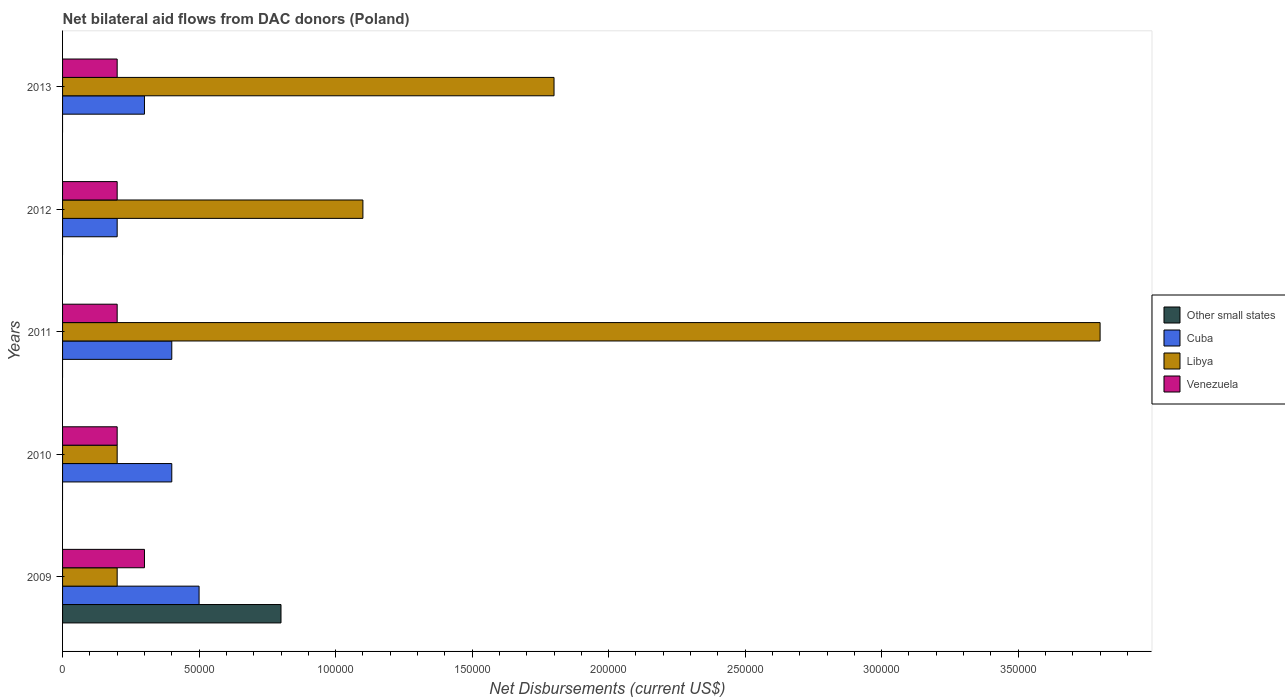How many groups of bars are there?
Your response must be concise. 5. Are the number of bars per tick equal to the number of legend labels?
Your answer should be compact. No. How many bars are there on the 4th tick from the bottom?
Ensure brevity in your answer.  3. What is the label of the 4th group of bars from the top?
Keep it short and to the point. 2010. What is the net bilateral aid flows in Other small states in 2010?
Your response must be concise. 0. Across all years, what is the minimum net bilateral aid flows in Venezuela?
Offer a terse response. 2.00e+04. What is the total net bilateral aid flows in Other small states in the graph?
Give a very brief answer. 8.00e+04. What is the difference between the net bilateral aid flows in Cuba in 2011 and that in 2012?
Your answer should be very brief. 2.00e+04. What is the difference between the net bilateral aid flows in Cuba in 2010 and the net bilateral aid flows in Venezuela in 2013?
Keep it short and to the point. 2.00e+04. What is the average net bilateral aid flows in Venezuela per year?
Your answer should be compact. 2.20e+04. What is the ratio of the net bilateral aid flows in Venezuela in 2009 to that in 2010?
Offer a terse response. 1.5. What is the difference between the highest and the lowest net bilateral aid flows in Other small states?
Ensure brevity in your answer.  8.00e+04. Is it the case that in every year, the sum of the net bilateral aid flows in Venezuela and net bilateral aid flows in Cuba is greater than the sum of net bilateral aid flows in Other small states and net bilateral aid flows in Libya?
Your answer should be compact. Yes. Is it the case that in every year, the sum of the net bilateral aid flows in Venezuela and net bilateral aid flows in Other small states is greater than the net bilateral aid flows in Libya?
Make the answer very short. No. How many bars are there?
Offer a terse response. 16. Are all the bars in the graph horizontal?
Keep it short and to the point. Yes. How many years are there in the graph?
Your answer should be very brief. 5. Where does the legend appear in the graph?
Make the answer very short. Center right. What is the title of the graph?
Provide a short and direct response. Net bilateral aid flows from DAC donors (Poland). Does "Montenegro" appear as one of the legend labels in the graph?
Your response must be concise. No. What is the label or title of the X-axis?
Your answer should be compact. Net Disbursements (current US$). What is the Net Disbursements (current US$) of Other small states in 2009?
Offer a very short reply. 8.00e+04. What is the Net Disbursements (current US$) in Venezuela in 2009?
Give a very brief answer. 3.00e+04. What is the Net Disbursements (current US$) in Other small states in 2010?
Your response must be concise. 0. What is the Net Disbursements (current US$) in Venezuela in 2010?
Give a very brief answer. 2.00e+04. What is the Net Disbursements (current US$) in Libya in 2011?
Your answer should be compact. 3.80e+05. What is the Net Disbursements (current US$) of Other small states in 2012?
Provide a succinct answer. 0. What is the Net Disbursements (current US$) in Venezuela in 2012?
Make the answer very short. 2.00e+04. What is the Net Disbursements (current US$) in Venezuela in 2013?
Offer a terse response. 2.00e+04. Across all years, what is the maximum Net Disbursements (current US$) of Venezuela?
Your response must be concise. 3.00e+04. Across all years, what is the minimum Net Disbursements (current US$) in Other small states?
Keep it short and to the point. 0. Across all years, what is the minimum Net Disbursements (current US$) of Cuba?
Your response must be concise. 2.00e+04. Across all years, what is the minimum Net Disbursements (current US$) in Libya?
Ensure brevity in your answer.  2.00e+04. Across all years, what is the minimum Net Disbursements (current US$) in Venezuela?
Provide a short and direct response. 2.00e+04. What is the total Net Disbursements (current US$) in Cuba in the graph?
Ensure brevity in your answer.  1.80e+05. What is the total Net Disbursements (current US$) of Libya in the graph?
Give a very brief answer. 7.10e+05. What is the difference between the Net Disbursements (current US$) of Libya in 2009 and that in 2010?
Keep it short and to the point. 0. What is the difference between the Net Disbursements (current US$) in Venezuela in 2009 and that in 2010?
Give a very brief answer. 10000. What is the difference between the Net Disbursements (current US$) in Libya in 2009 and that in 2011?
Provide a short and direct response. -3.60e+05. What is the difference between the Net Disbursements (current US$) of Venezuela in 2009 and that in 2011?
Offer a terse response. 10000. What is the difference between the Net Disbursements (current US$) in Cuba in 2010 and that in 2011?
Offer a terse response. 0. What is the difference between the Net Disbursements (current US$) of Libya in 2010 and that in 2011?
Give a very brief answer. -3.60e+05. What is the difference between the Net Disbursements (current US$) of Venezuela in 2010 and that in 2011?
Make the answer very short. 0. What is the difference between the Net Disbursements (current US$) of Libya in 2010 and that in 2012?
Make the answer very short. -9.00e+04. What is the difference between the Net Disbursements (current US$) in Venezuela in 2010 and that in 2012?
Your response must be concise. 0. What is the difference between the Net Disbursements (current US$) of Venezuela in 2010 and that in 2013?
Give a very brief answer. 0. What is the difference between the Net Disbursements (current US$) of Cuba in 2011 and that in 2012?
Provide a short and direct response. 2.00e+04. What is the difference between the Net Disbursements (current US$) of Venezuela in 2011 and that in 2012?
Offer a very short reply. 0. What is the difference between the Net Disbursements (current US$) in Cuba in 2011 and that in 2013?
Keep it short and to the point. 10000. What is the difference between the Net Disbursements (current US$) in Venezuela in 2012 and that in 2013?
Your response must be concise. 0. What is the difference between the Net Disbursements (current US$) of Other small states in 2009 and the Net Disbursements (current US$) of Libya in 2010?
Offer a terse response. 6.00e+04. What is the difference between the Net Disbursements (current US$) in Cuba in 2009 and the Net Disbursements (current US$) in Libya in 2010?
Keep it short and to the point. 3.00e+04. What is the difference between the Net Disbursements (current US$) in Cuba in 2009 and the Net Disbursements (current US$) in Venezuela in 2010?
Your response must be concise. 3.00e+04. What is the difference between the Net Disbursements (current US$) of Cuba in 2009 and the Net Disbursements (current US$) of Libya in 2011?
Your answer should be very brief. -3.30e+05. What is the difference between the Net Disbursements (current US$) of Other small states in 2009 and the Net Disbursements (current US$) of Cuba in 2012?
Give a very brief answer. 6.00e+04. What is the difference between the Net Disbursements (current US$) in Other small states in 2009 and the Net Disbursements (current US$) in Libya in 2012?
Make the answer very short. -3.00e+04. What is the difference between the Net Disbursements (current US$) of Other small states in 2009 and the Net Disbursements (current US$) of Venezuela in 2012?
Your answer should be very brief. 6.00e+04. What is the difference between the Net Disbursements (current US$) in Cuba in 2009 and the Net Disbursements (current US$) in Libya in 2012?
Give a very brief answer. -6.00e+04. What is the difference between the Net Disbursements (current US$) in Other small states in 2009 and the Net Disbursements (current US$) in Cuba in 2013?
Offer a terse response. 5.00e+04. What is the difference between the Net Disbursements (current US$) of Other small states in 2009 and the Net Disbursements (current US$) of Venezuela in 2013?
Make the answer very short. 6.00e+04. What is the difference between the Net Disbursements (current US$) of Libya in 2009 and the Net Disbursements (current US$) of Venezuela in 2013?
Ensure brevity in your answer.  0. What is the difference between the Net Disbursements (current US$) of Cuba in 2010 and the Net Disbursements (current US$) of Venezuela in 2011?
Your answer should be compact. 2.00e+04. What is the difference between the Net Disbursements (current US$) of Cuba in 2010 and the Net Disbursements (current US$) of Libya in 2012?
Provide a short and direct response. -7.00e+04. What is the difference between the Net Disbursements (current US$) in Cuba in 2010 and the Net Disbursements (current US$) in Libya in 2013?
Keep it short and to the point. -1.40e+05. What is the difference between the Net Disbursements (current US$) of Cuba in 2010 and the Net Disbursements (current US$) of Venezuela in 2013?
Provide a short and direct response. 2.00e+04. What is the difference between the Net Disbursements (current US$) of Libya in 2011 and the Net Disbursements (current US$) of Venezuela in 2012?
Give a very brief answer. 3.60e+05. What is the difference between the Net Disbursements (current US$) in Cuba in 2012 and the Net Disbursements (current US$) in Libya in 2013?
Provide a succinct answer. -1.60e+05. What is the difference between the Net Disbursements (current US$) of Libya in 2012 and the Net Disbursements (current US$) of Venezuela in 2013?
Your answer should be compact. 9.00e+04. What is the average Net Disbursements (current US$) in Other small states per year?
Your answer should be very brief. 1.60e+04. What is the average Net Disbursements (current US$) in Cuba per year?
Offer a terse response. 3.60e+04. What is the average Net Disbursements (current US$) in Libya per year?
Make the answer very short. 1.42e+05. What is the average Net Disbursements (current US$) of Venezuela per year?
Provide a short and direct response. 2.20e+04. In the year 2009, what is the difference between the Net Disbursements (current US$) of Other small states and Net Disbursements (current US$) of Cuba?
Make the answer very short. 3.00e+04. In the year 2009, what is the difference between the Net Disbursements (current US$) in Other small states and Net Disbursements (current US$) in Libya?
Make the answer very short. 6.00e+04. In the year 2009, what is the difference between the Net Disbursements (current US$) of Cuba and Net Disbursements (current US$) of Venezuela?
Ensure brevity in your answer.  2.00e+04. In the year 2010, what is the difference between the Net Disbursements (current US$) of Cuba and Net Disbursements (current US$) of Libya?
Give a very brief answer. 2.00e+04. In the year 2011, what is the difference between the Net Disbursements (current US$) in Cuba and Net Disbursements (current US$) in Venezuela?
Make the answer very short. 2.00e+04. In the year 2012, what is the difference between the Net Disbursements (current US$) in Cuba and Net Disbursements (current US$) in Libya?
Your answer should be compact. -9.00e+04. In the year 2012, what is the difference between the Net Disbursements (current US$) in Libya and Net Disbursements (current US$) in Venezuela?
Give a very brief answer. 9.00e+04. In the year 2013, what is the difference between the Net Disbursements (current US$) of Cuba and Net Disbursements (current US$) of Venezuela?
Offer a terse response. 10000. In the year 2013, what is the difference between the Net Disbursements (current US$) in Libya and Net Disbursements (current US$) in Venezuela?
Your response must be concise. 1.60e+05. What is the ratio of the Net Disbursements (current US$) in Cuba in 2009 to that in 2010?
Provide a short and direct response. 1.25. What is the ratio of the Net Disbursements (current US$) of Venezuela in 2009 to that in 2010?
Provide a succinct answer. 1.5. What is the ratio of the Net Disbursements (current US$) of Libya in 2009 to that in 2011?
Your answer should be compact. 0.05. What is the ratio of the Net Disbursements (current US$) of Venezuela in 2009 to that in 2011?
Your response must be concise. 1.5. What is the ratio of the Net Disbursements (current US$) of Libya in 2009 to that in 2012?
Keep it short and to the point. 0.18. What is the ratio of the Net Disbursements (current US$) of Venezuela in 2009 to that in 2012?
Your response must be concise. 1.5. What is the ratio of the Net Disbursements (current US$) of Libya in 2009 to that in 2013?
Ensure brevity in your answer.  0.11. What is the ratio of the Net Disbursements (current US$) in Libya in 2010 to that in 2011?
Provide a succinct answer. 0.05. What is the ratio of the Net Disbursements (current US$) in Venezuela in 2010 to that in 2011?
Ensure brevity in your answer.  1. What is the ratio of the Net Disbursements (current US$) of Libya in 2010 to that in 2012?
Offer a very short reply. 0.18. What is the ratio of the Net Disbursements (current US$) of Venezuela in 2010 to that in 2012?
Your answer should be compact. 1. What is the ratio of the Net Disbursements (current US$) in Venezuela in 2010 to that in 2013?
Your answer should be very brief. 1. What is the ratio of the Net Disbursements (current US$) in Cuba in 2011 to that in 2012?
Offer a terse response. 2. What is the ratio of the Net Disbursements (current US$) in Libya in 2011 to that in 2012?
Provide a short and direct response. 3.45. What is the ratio of the Net Disbursements (current US$) in Venezuela in 2011 to that in 2012?
Offer a very short reply. 1. What is the ratio of the Net Disbursements (current US$) of Cuba in 2011 to that in 2013?
Give a very brief answer. 1.33. What is the ratio of the Net Disbursements (current US$) in Libya in 2011 to that in 2013?
Provide a short and direct response. 2.11. What is the ratio of the Net Disbursements (current US$) of Libya in 2012 to that in 2013?
Give a very brief answer. 0.61. What is the difference between the highest and the second highest Net Disbursements (current US$) of Venezuela?
Offer a terse response. 10000. What is the difference between the highest and the lowest Net Disbursements (current US$) in Cuba?
Your response must be concise. 3.00e+04. 